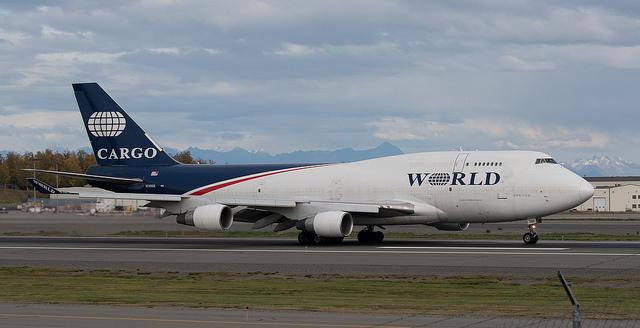What does the writing on the plane say?
Quick response, please. Cargo world. What is the name of the plane?
Answer briefly. World. What airline owns the plane?
Short answer required. World. How many windows are on the plane?
Quick response, please. 10. What does the wing say?
Short answer required. Cargo. Which way is the nose of the plane pointing?
Answer briefly. Right. Is this a two passenger plane?
Be succinct. No. Is this a cargo plane?
Short answer required. Yes. What colors are the plane?
Be succinct. White and blue. Are there windows on the plane?
Quick response, please. Yes. Where is the fence?
Be succinct. Background. Can you see the pilot of the plane?
Quick response, please. No. What direction is the plane going?
Quick response, please. Right. What is the name of the airline?
Keep it brief. Cargo. What company owns this plane?
Write a very short answer. Cargo. Are there any vehicles around the plane?
Concise answer only. No. What is the main color of the fuselage?
Write a very short answer. White. What color is the planes tail?
Write a very short answer. Blue. Is the airlines logo hands?
Write a very short answer. No. What words are on the plane?
Answer briefly. Cargo world. 